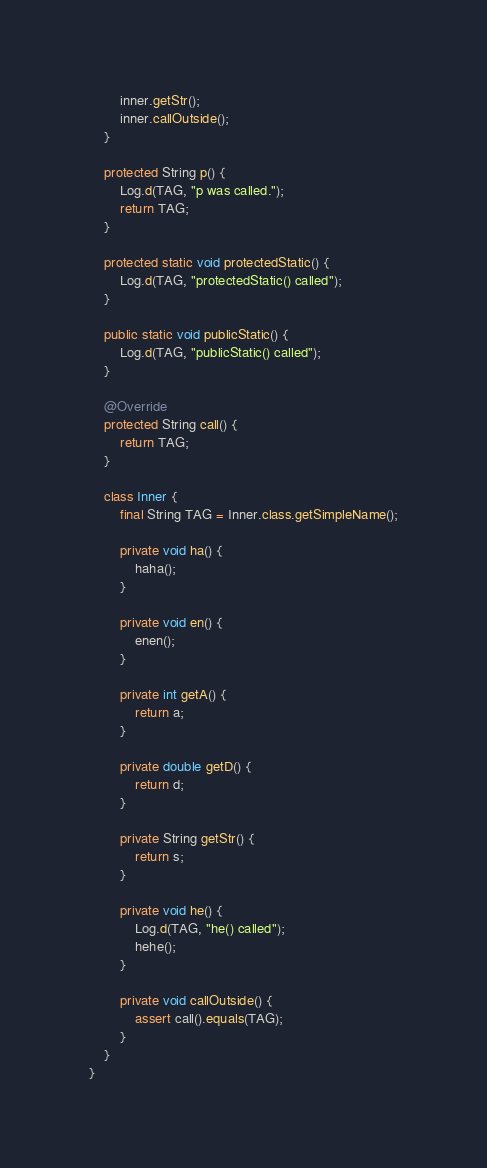<code> <loc_0><loc_0><loc_500><loc_500><_Java_>        inner.getStr();
        inner.callOutside();
    }

    protected String p() {
        Log.d(TAG, "p was called.");
        return TAG;
    }

    protected static void protectedStatic() {
        Log.d(TAG, "protectedStatic() called");
    }

    public static void publicStatic() {
        Log.d(TAG, "publicStatic() called");
    }

    @Override
    protected String call() {
        return TAG;
    }

    class Inner {
        final String TAG = Inner.class.getSimpleName();

        private void ha() {
            haha();
        }

        private void en() {
            enen();
        }

        private int getA() {
            return a;
        }

        private double getD() {
            return d;
        }

        private String getStr() {
            return s;
        }

        private void he() {
            Log.d(TAG, "he() called");
            hehe();
        }

        private void callOutside() {
            assert call().equals(TAG);
        }
    }
}</code> 